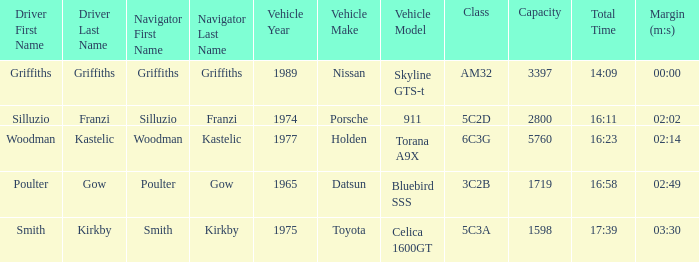What driver had a total time of 16:58? Poulter. 